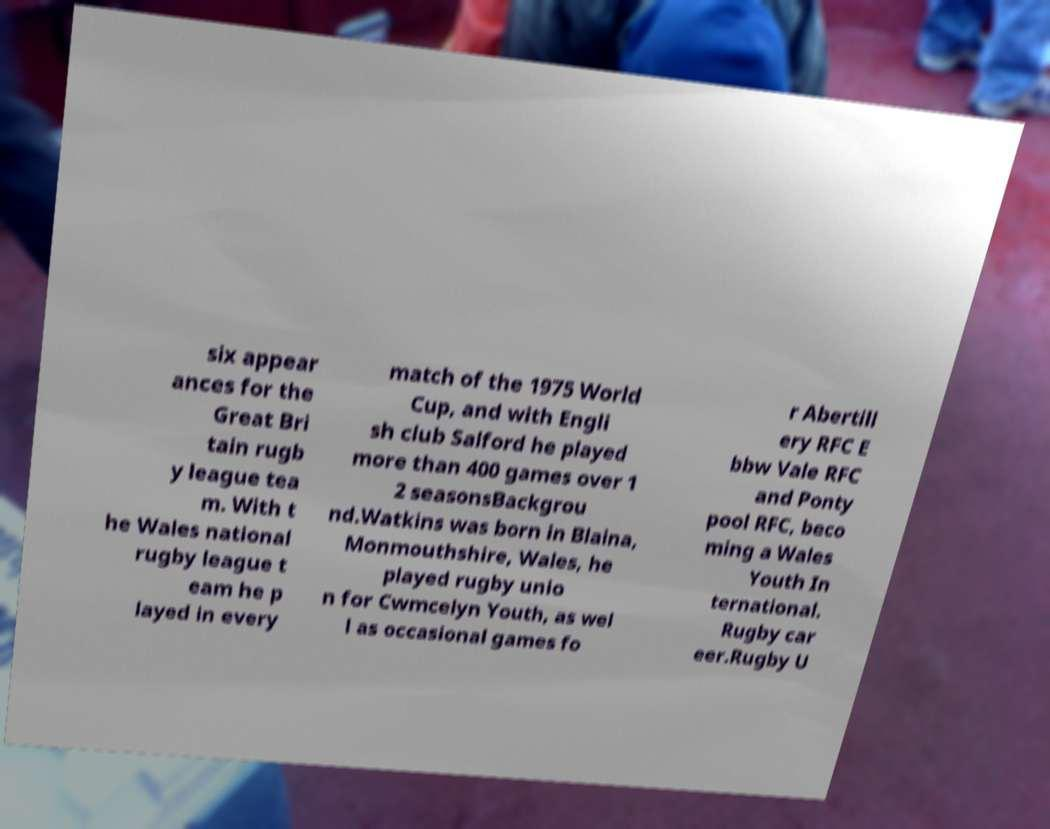There's text embedded in this image that I need extracted. Can you transcribe it verbatim? six appear ances for the Great Bri tain rugb y league tea m. With t he Wales national rugby league t eam he p layed in every match of the 1975 World Cup, and with Engli sh club Salford he played more than 400 games over 1 2 seasonsBackgrou nd.Watkins was born in Blaina, Monmouthshire, Wales, he played rugby unio n for Cwmcelyn Youth, as wel l as occasional games fo r Abertill ery RFC E bbw Vale RFC and Ponty pool RFC, beco ming a Wales Youth In ternational. Rugby car eer.Rugby U 